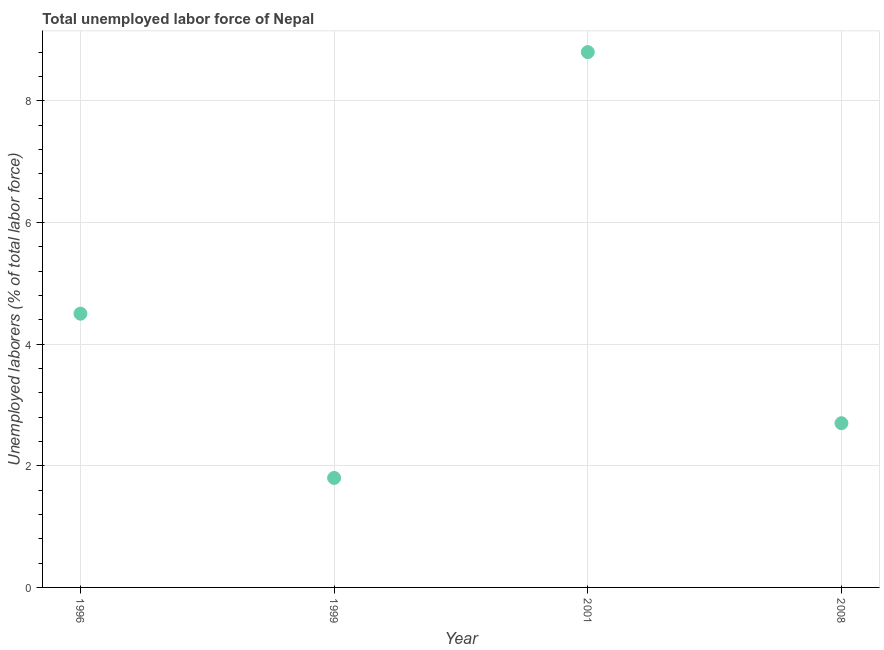What is the total unemployed labour force in 2001?
Give a very brief answer. 8.8. Across all years, what is the maximum total unemployed labour force?
Ensure brevity in your answer.  8.8. Across all years, what is the minimum total unemployed labour force?
Make the answer very short. 1.8. What is the sum of the total unemployed labour force?
Your response must be concise. 17.8. What is the difference between the total unemployed labour force in 1996 and 2008?
Ensure brevity in your answer.  1.8. What is the average total unemployed labour force per year?
Give a very brief answer. 4.45. What is the median total unemployed labour force?
Your answer should be compact. 3.6. What is the ratio of the total unemployed labour force in 1996 to that in 2001?
Your answer should be compact. 0.51. Is the total unemployed labour force in 1996 less than that in 2001?
Give a very brief answer. Yes. What is the difference between the highest and the second highest total unemployed labour force?
Your response must be concise. 4.3. What is the difference between the highest and the lowest total unemployed labour force?
Give a very brief answer. 7. Does the total unemployed labour force monotonically increase over the years?
Offer a terse response. No. How many years are there in the graph?
Your answer should be very brief. 4. What is the difference between two consecutive major ticks on the Y-axis?
Offer a very short reply. 2. Does the graph contain any zero values?
Your answer should be compact. No. Does the graph contain grids?
Keep it short and to the point. Yes. What is the title of the graph?
Provide a succinct answer. Total unemployed labor force of Nepal. What is the label or title of the Y-axis?
Provide a succinct answer. Unemployed laborers (% of total labor force). What is the Unemployed laborers (% of total labor force) in 1999?
Your answer should be very brief. 1.8. What is the Unemployed laborers (% of total labor force) in 2001?
Provide a short and direct response. 8.8. What is the Unemployed laborers (% of total labor force) in 2008?
Your answer should be compact. 2.7. What is the difference between the Unemployed laborers (% of total labor force) in 1996 and 1999?
Your answer should be very brief. 2.7. What is the difference between the Unemployed laborers (% of total labor force) in 1996 and 2001?
Give a very brief answer. -4.3. What is the difference between the Unemployed laborers (% of total labor force) in 1999 and 2008?
Offer a terse response. -0.9. What is the ratio of the Unemployed laborers (% of total labor force) in 1996 to that in 1999?
Offer a terse response. 2.5. What is the ratio of the Unemployed laborers (% of total labor force) in 1996 to that in 2001?
Your response must be concise. 0.51. What is the ratio of the Unemployed laborers (% of total labor force) in 1996 to that in 2008?
Offer a terse response. 1.67. What is the ratio of the Unemployed laborers (% of total labor force) in 1999 to that in 2001?
Your answer should be very brief. 0.2. What is the ratio of the Unemployed laborers (% of total labor force) in 1999 to that in 2008?
Offer a terse response. 0.67. What is the ratio of the Unemployed laborers (% of total labor force) in 2001 to that in 2008?
Offer a very short reply. 3.26. 